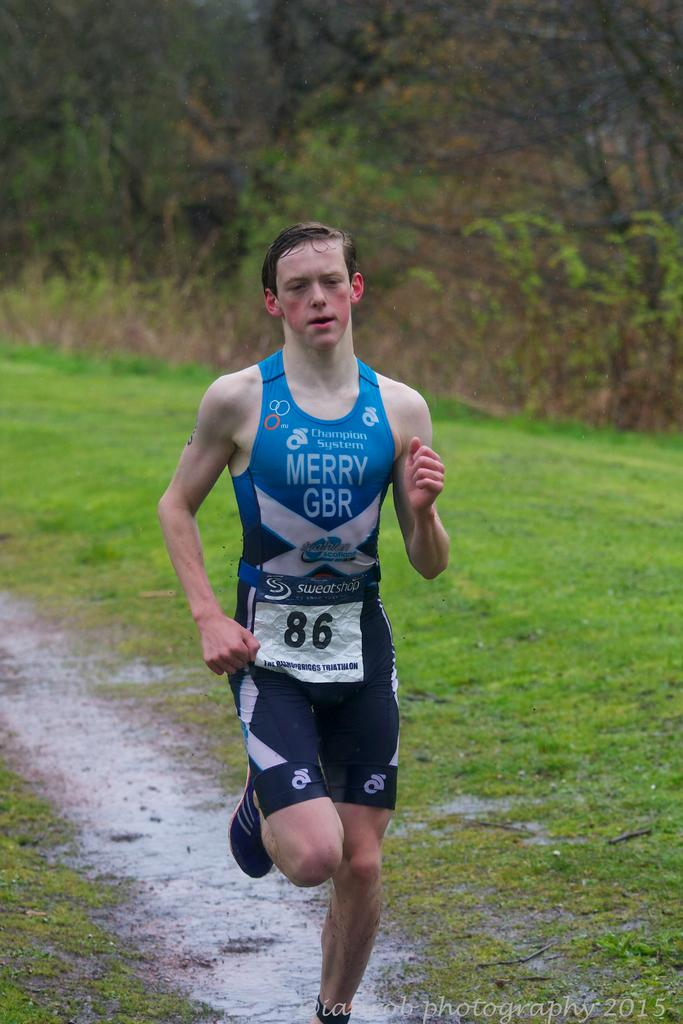<image>
Summarize the visual content of the image. a man running with the number 86 on his body 